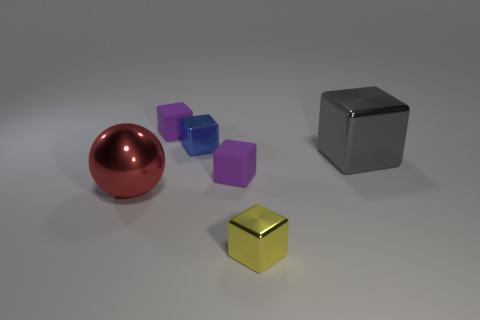Subtract all large gray metal cubes. How many cubes are left? 4 Add 2 metal objects. How many objects exist? 8 Subtract all purple cubes. How many cubes are left? 3 Subtract 1 cubes. How many cubes are left? 4 Add 1 large cyan shiny spheres. How many large cyan shiny spheres exist? 1 Subtract 0 gray balls. How many objects are left? 6 Subtract all cubes. How many objects are left? 1 Subtract all gray cubes. Subtract all green cylinders. How many cubes are left? 4 Subtract all brown balls. How many purple blocks are left? 2 Subtract all small red cubes. Subtract all rubber blocks. How many objects are left? 4 